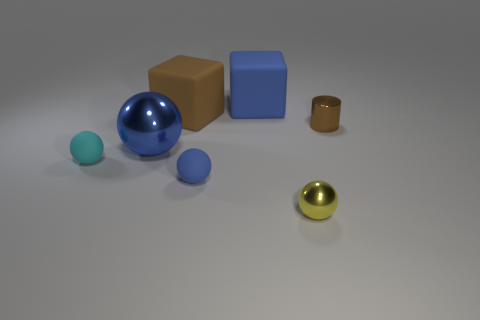There is a thing that is behind the brown rubber block; how many metal balls are on the left side of it? 1 